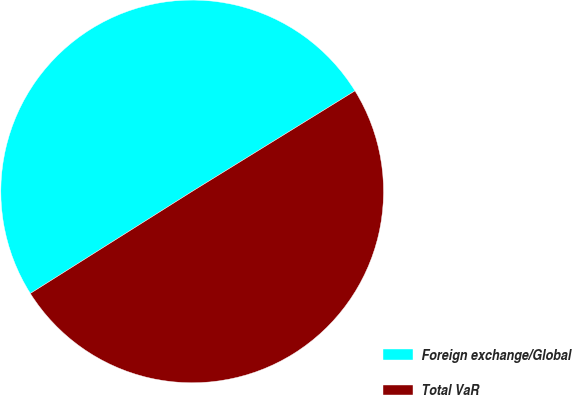<chart> <loc_0><loc_0><loc_500><loc_500><pie_chart><fcel>Foreign exchange/Global<fcel>Total VaR<nl><fcel>50.15%<fcel>49.85%<nl></chart> 